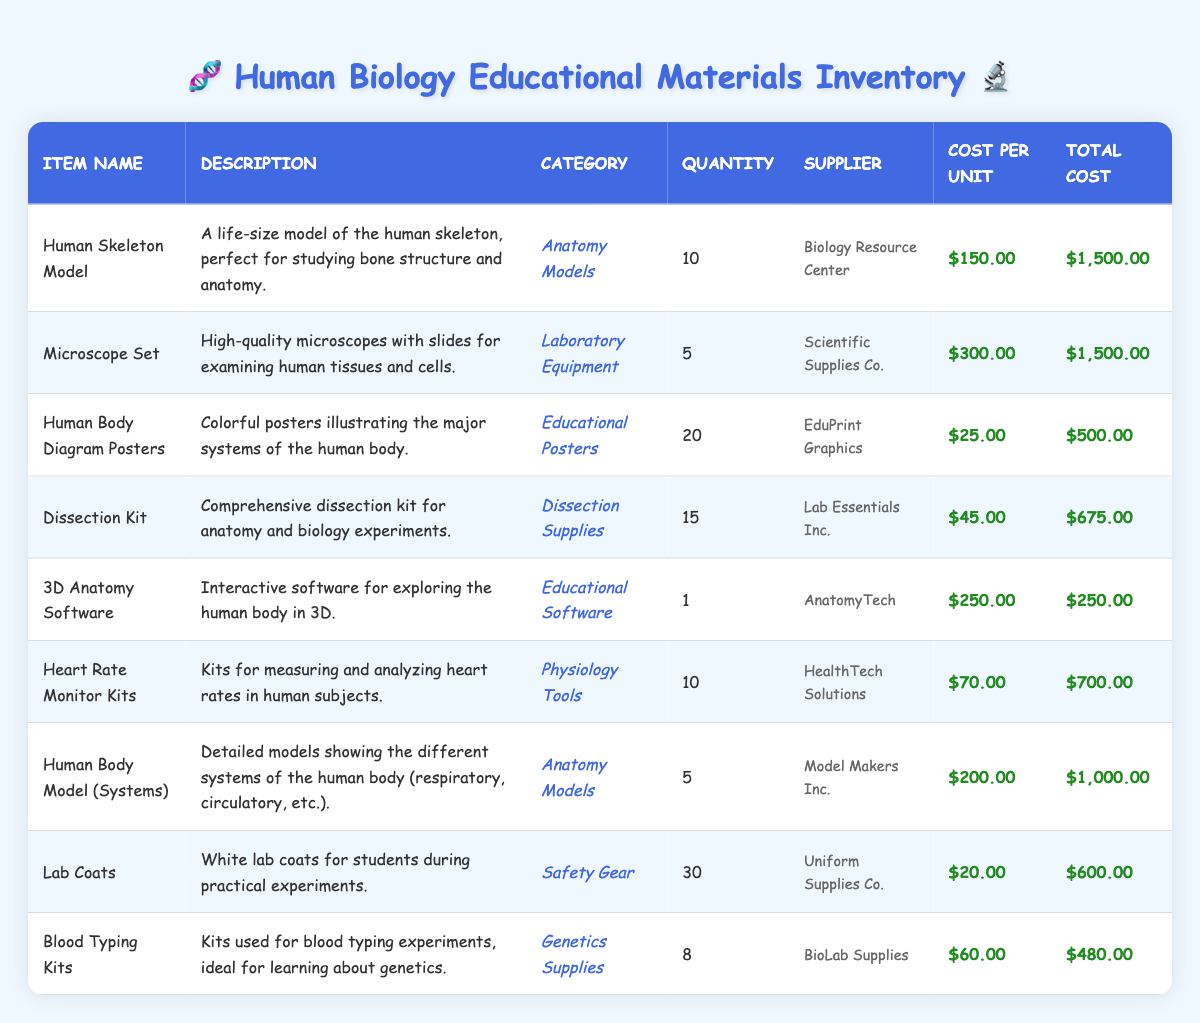What is the total quantity of Human Skeleton Models available? The table shows that there are 10 Human Skeleton Models listed under the quantity column.
Answer: 10 How much do the Lab Coats cost in total? The table indicates that there are 30 Lab Coats, each costing $20. To find the total cost, multiply the quantity by the cost per unit: 30 * 20 = 600.
Answer: 600 Is the Microscope Set categorized as Anatomy Models? The table categorizes the Microscope Set under Laboratory Equipment, not Anatomy Models. Therefore, the statement is false.
Answer: No Which item has the highest total cost? By reviewing the total cost column, the Human Skeleton Model and Microscope Set both have a total cost of $1500, which is the highest among all items listed.
Answer: Human Skeleton Model and Microscope Set What is the average cost per unit of the Dissection Kits and Blood Typing Kits? The Dissection Kits cost $45 each and there are 15 of them. The Blood Typing Kits cost $60 each and there are 8 of them. To find the average cost per unit, sum the costs and divide by the number of data points: (45 + 60)/2 = 52.5.
Answer: 52.5 How many more Human Body Model (Systems) are there compared to the Heart Rate Monitor Kits? The table shows that there are 5 Human Body Models (Systems) and 10 Heart Rate Monitor Kits. Subtracting these gives 5 - 10 = -5, meaning there are 5 fewer Human Body Models.
Answer: 5 fewer Which supplier provides the most types of materials? By counting the suppliers from the table, we see each supplier is listed with one item category. This means none of the suppliers are providing multiple types of materials since each listed item is sourced from a different supplier.
Answer: None What would the total cost be if we added another 5 Blood Typing Kits? The current total cost for 8 Blood Typing Kits is $480. Each Blood Typing Kit costs $60, so adding 5 more would cost an additional 5 * 60 = 300. The new total cost would be 480 + 300 = 780.
Answer: 780 Is there a higher quantity of Lab Coats than of Human Body Diagram Posters? The quantity of Lab Coats is 30, and the quantity of Human Body Diagram Posters is 20. Therefore, 30 is greater than 20, making the statement true.
Answer: Yes 